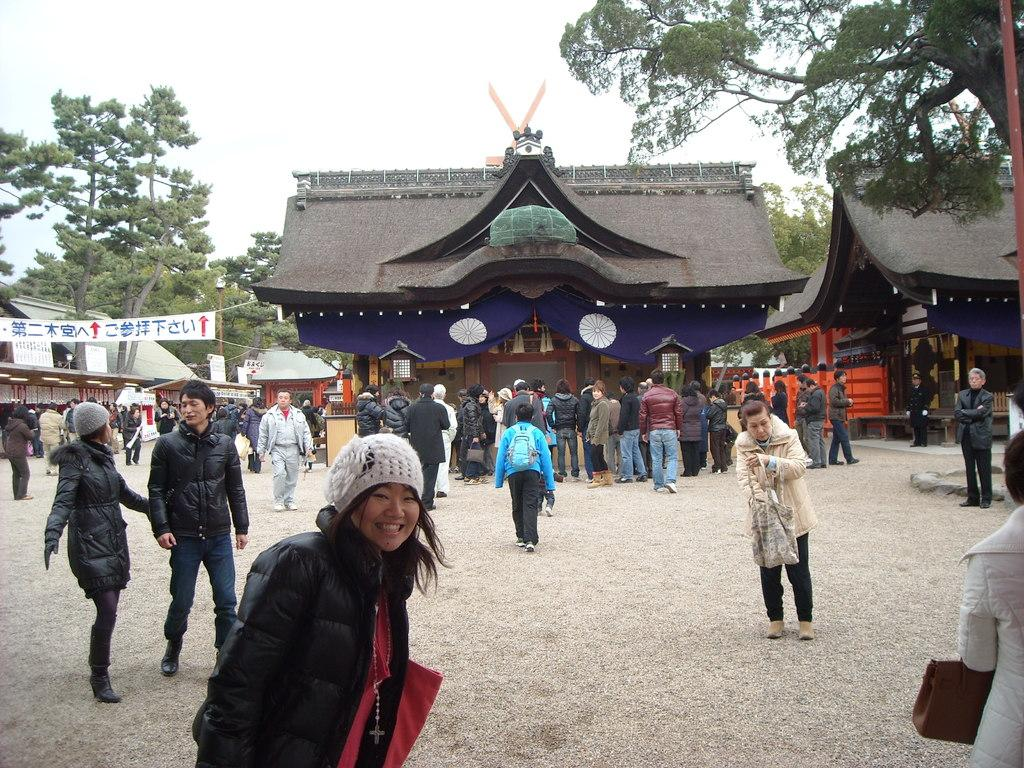What is the main subject in the foreground of the image? There is a crowd in the foreground of the image. Where is the crowd located? The crowd is on the road. What can be seen in the background of the image? There are posts, houses, shops, trees, benches, and the sky visible in the background of the image. Can you describe the time of day the image was likely taken? The image is likely taken during the day, as the sky is visible and there is no indication of darkness. What type of decision can be seen being made by the flame in the image? There is no flame present in the image, so no decision can be attributed to a flame. 